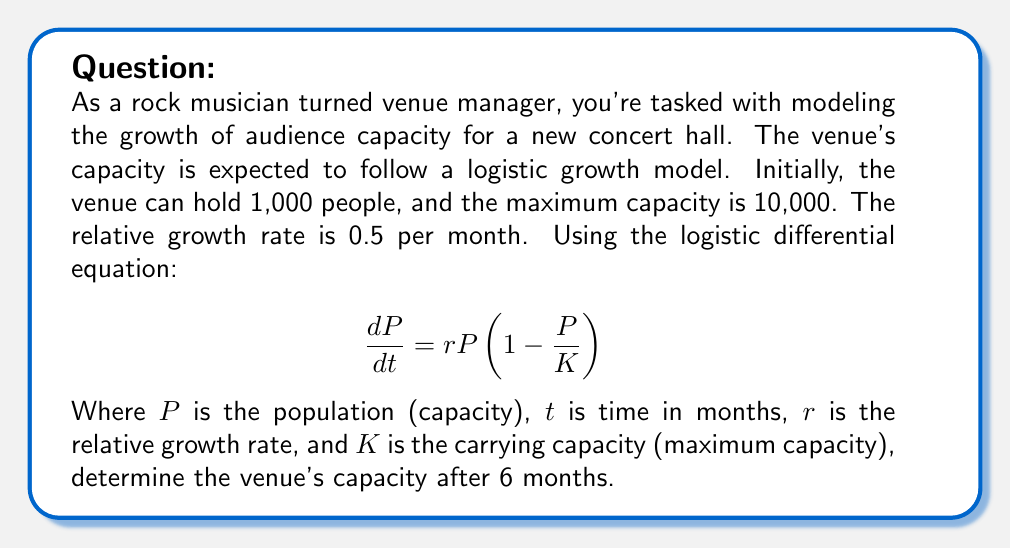Can you answer this question? Let's approach this step-by-step:

1) We're given the logistic differential equation:
   $$\frac{dP}{dt} = rP(1-\frac{P}{K})$$

2) We know:
   - Initial capacity, $P_0 = 1,000$
   - Maximum capacity, $K = 10,000$
   - Relative growth rate, $r = 0.5$ per month
   - We need to find $P$ when $t = 6$ months

3) The solution to the logistic differential equation is:
   $$P(t) = \frac{KP_0}{P_0 + (K-P_0)e^{-rt}}$$

4) Let's substitute our known values:
   $$P(t) = \frac{10000 \cdot 1000}{1000 + (10000-1000)e^{-0.5t}}$$

5) Simplify:
   $$P(t) = \frac{10,000,000}{1000 + 9000e^{-0.5t}}$$

6) Now, we want to find $P(6)$, so let's substitute $t=6$:
   $$P(6) = \frac{10,000,000}{1000 + 9000e^{-0.5(6)}}$$

7) Calculate $e^{-0.5(6)} \approx 0.0498$:
   $$P(6) = \frac{10,000,000}{1000 + 9000(0.0498)}$$

8) Simplify:
   $$P(6) = \frac{10,000,000}{1000 + 448.2} = \frac{10,000,000}{1448.2}$$

9) Calculate the final result:
   $$P(6) \approx 6,905.54$$

Therefore, after 6 months, the venue's capacity will be approximately 6,906 people (rounding to the nearest whole person).
Answer: 6,906 people 